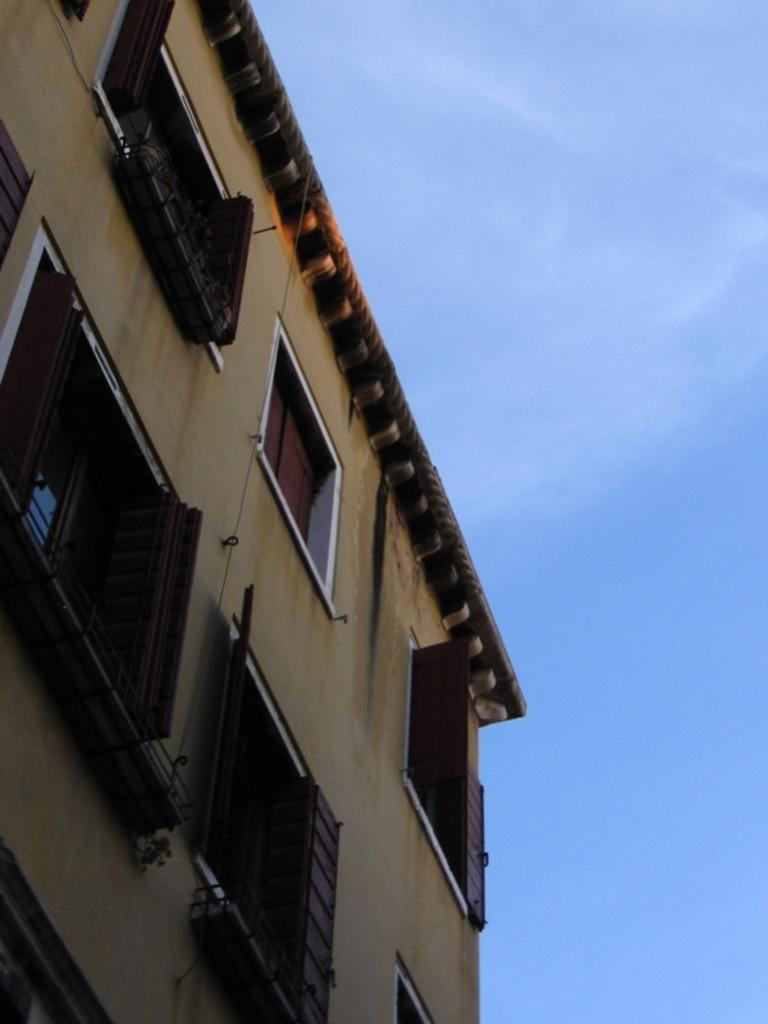What type of structure is present in the image? There is a building in the image. What can be seen in the background of the image? The sky is visible in the background of the image. How many snails can be seen crawling on the building in the image? There are no snails present in the image; it only features a building and the sky in the background. 